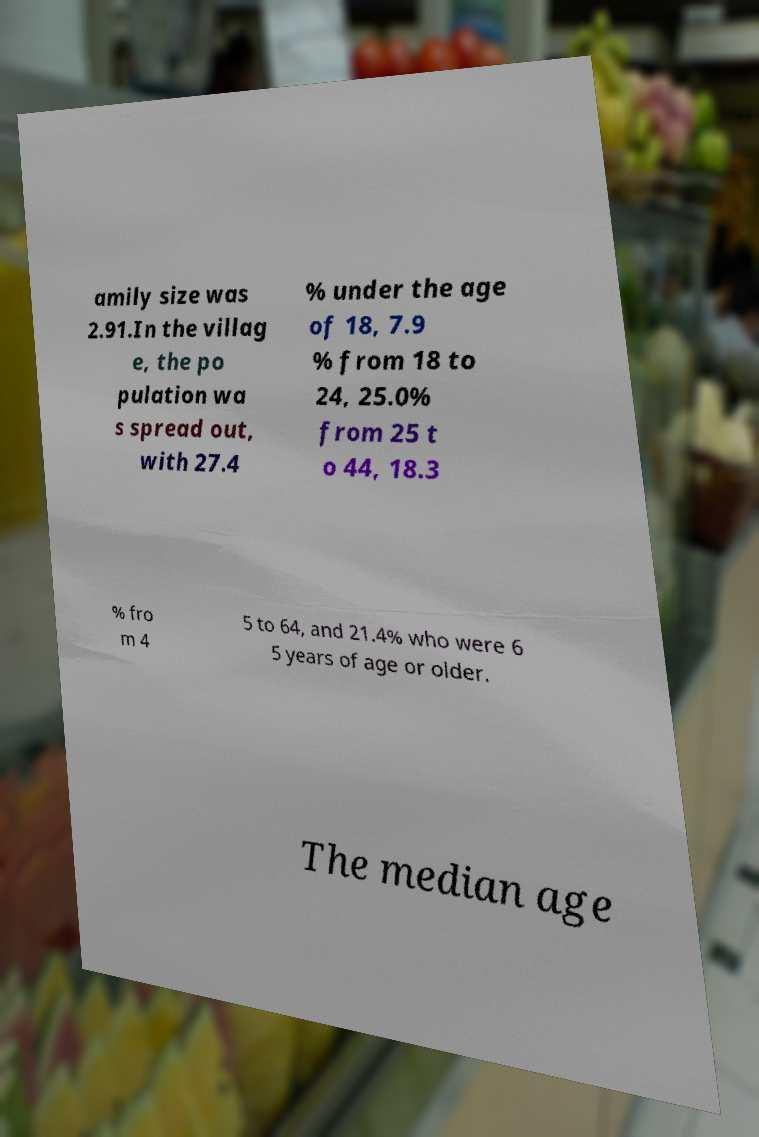Could you extract and type out the text from this image? amily size was 2.91.In the villag e, the po pulation wa s spread out, with 27.4 % under the age of 18, 7.9 % from 18 to 24, 25.0% from 25 t o 44, 18.3 % fro m 4 5 to 64, and 21.4% who were 6 5 years of age or older. The median age 